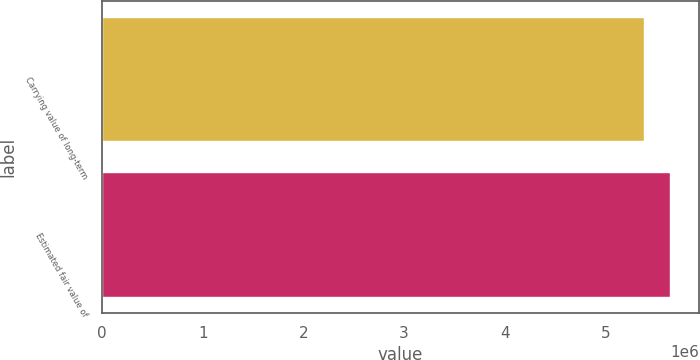Convert chart to OTSL. <chart><loc_0><loc_0><loc_500><loc_500><bar_chart><fcel>Carrying value of long-term<fcel>Estimated fair value of<nl><fcel>5.38334e+06<fcel>5.64553e+06<nl></chart> 